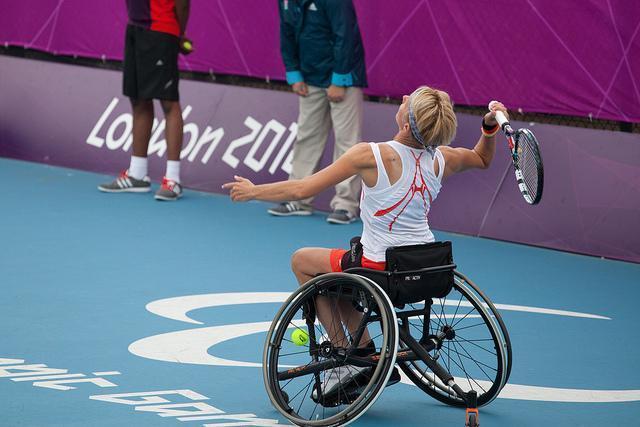In which class of the sport does the tennis player compete?
Choose the right answer and clarify with the format: 'Answer: answer
Rationale: rationale.'
Options: College, amateur, juniors, wheelchair. Answer: wheelchair.
Rationale: She is playing in a wheelchair league. 